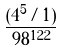Convert formula to latex. <formula><loc_0><loc_0><loc_500><loc_500>\frac { ( 4 ^ { 5 } / 1 ) } { 9 8 ^ { 1 2 2 } }</formula> 